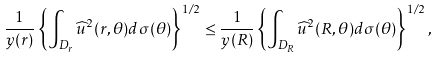Convert formula to latex. <formula><loc_0><loc_0><loc_500><loc_500>\frac { 1 } { y ( r ) } \left \{ \int _ { D _ { r } } \widehat { u } ^ { 2 } ( r , \theta ) d \sigma ( \theta ) \right \} ^ { 1 / 2 } \leq \frac { 1 } { y ( R ) } \left \{ \int _ { D _ { R } } \widehat { u } ^ { 2 } ( R , \theta ) d \sigma ( \theta ) \right \} ^ { 1 / 2 } ,</formula> 